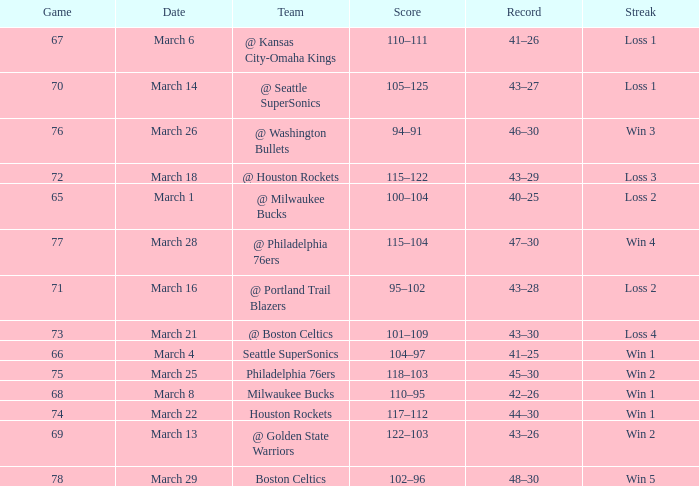What is the lowest Game, when Date is March 21? 73.0. 